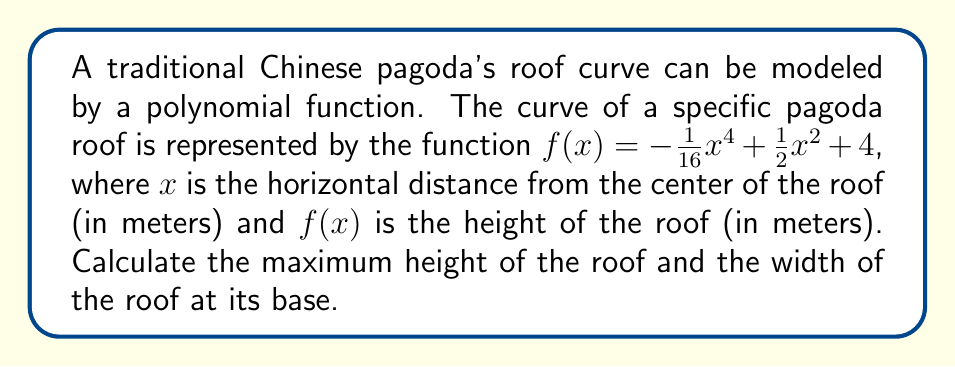Help me with this question. 1) To find the maximum height of the roof, we need to find the maximum value of $f(x)$. This occurs at the center of the roof where $x = 0$.

   $f(0) = -\frac{1}{16}(0)^4 + \frac{1}{2}(0)^2 + 4 = 4$

   So, the maximum height of the roof is 4 meters.

2) To find the width of the roof at its base, we need to find the x-intercepts of the function. This is where $f(x) = 0$.

   $0 = -\frac{1}{16}x^4 + \frac{1}{2}x^2 + 4$
   $\frac{1}{16}x^4 - \frac{1}{2}x^2 - 4 = 0$

3) Let $u = x^2$. Then the equation becomes:

   $\frac{1}{16}u^2 - \frac{1}{2}u - 4 = 0$

4) This is a quadratic in $u$. We can solve it using the quadratic formula:
   
   $u = \frac{-b \pm \sqrt{b^2 - 4ac}}{2a}$

   Where $a = \frac{1}{16}$, $b = -\frac{1}{2}$, and $c = -4$

5) Substituting these values:

   $u = \frac{\frac{1}{2} \pm \sqrt{(\frac{1}{2})^2 - 4(\frac{1}{16})(-4)}}{2(\frac{1}{16})}$
   $= \frac{\frac{1}{2} \pm \sqrt{\frac{1}{4} + 1}}{2(\frac{1}{16})}$
   $= \frac{\frac{1}{2} \pm \sqrt{\frac{5}{4}}}{2(\frac{1}{16})}$
   $= 4 \pm 4\sqrt{\frac{5}{4}}$

6) Since $u = x^2$, and we're looking for positive values of $x$:

   $x = \pm\sqrt{4 + 4\sqrt{\frac{5}{4}}}$

7) The width of the roof is the distance between these two x-intercepts:

   Width $= 2\sqrt{4 + 4\sqrt{\frac{5}{4}}} = 2\sqrt{4(1 + \sqrt{\frac{5}{4}})} = 4\sqrt{1 + \sqrt{\frac{5}{4}}}$ meters
Answer: Maximum height: 4 m; Width: $4\sqrt{1 + \sqrt{\frac{5}{4}}}$ m 